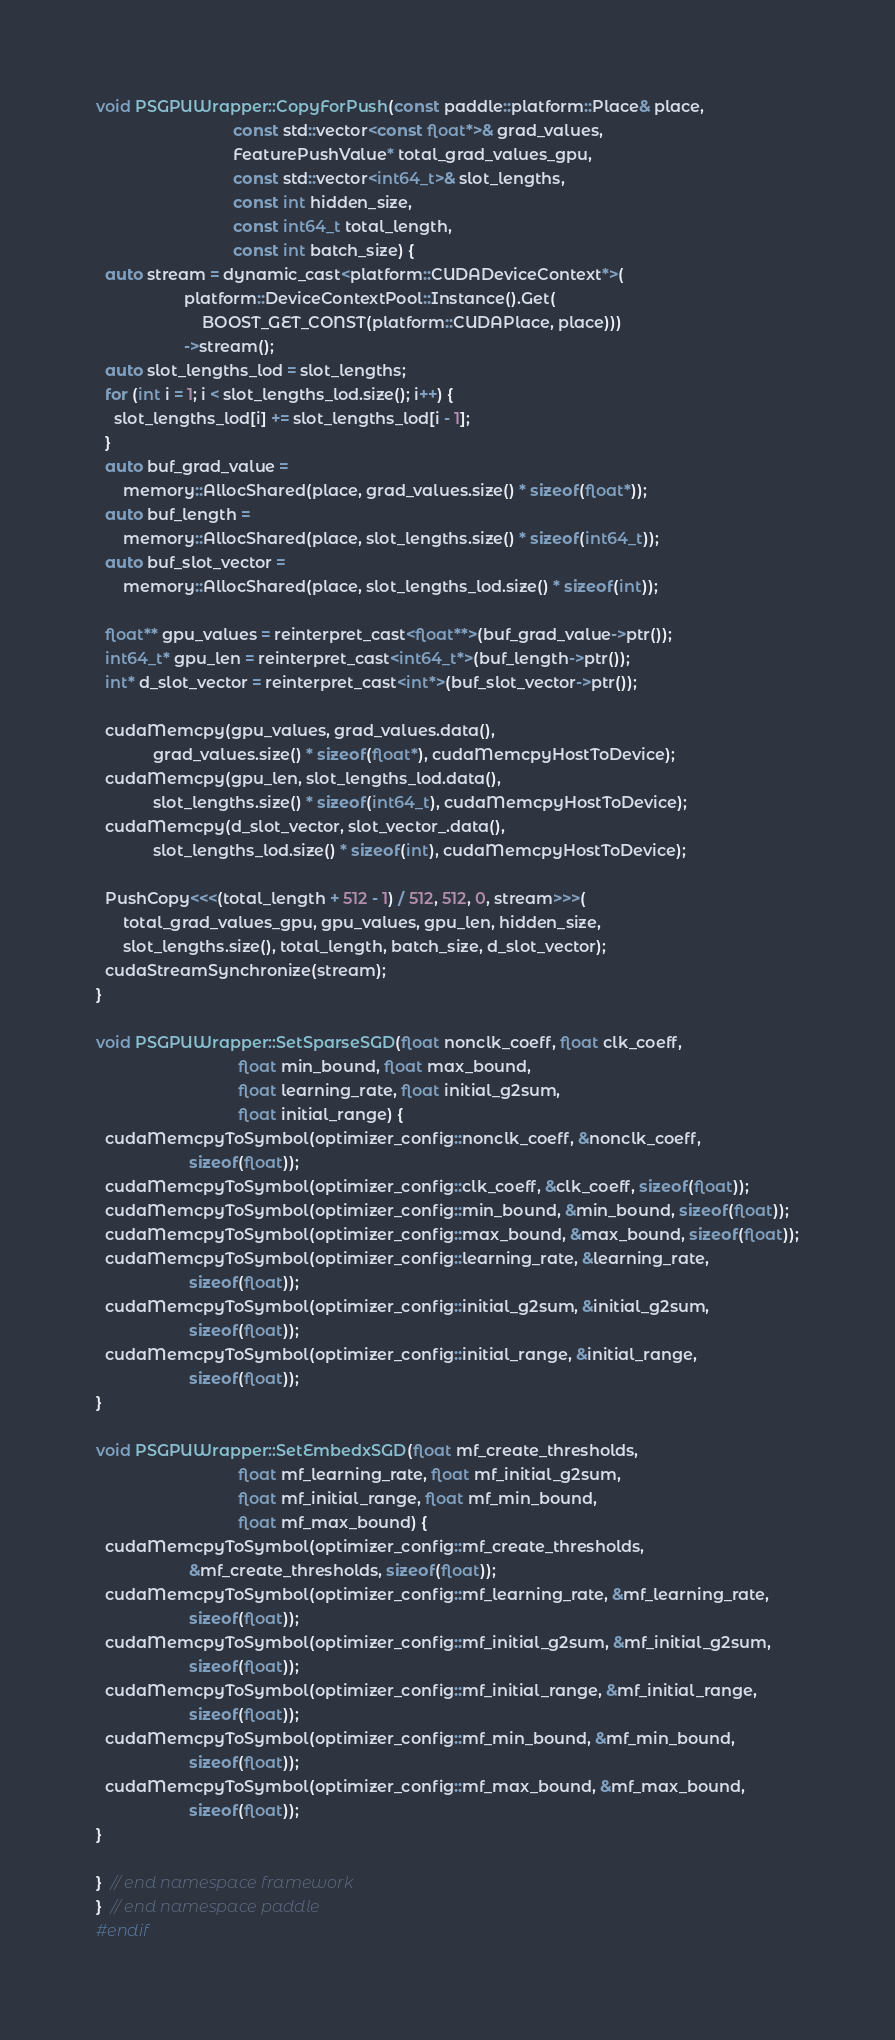Convert code to text. <code><loc_0><loc_0><loc_500><loc_500><_Cuda_>void PSGPUWrapper::CopyForPush(const paddle::platform::Place& place,
                               const std::vector<const float*>& grad_values,
                               FeaturePushValue* total_grad_values_gpu,
                               const std::vector<int64_t>& slot_lengths,
                               const int hidden_size,
                               const int64_t total_length,
                               const int batch_size) {
  auto stream = dynamic_cast<platform::CUDADeviceContext*>(
                    platform::DeviceContextPool::Instance().Get(
                        BOOST_GET_CONST(platform::CUDAPlace, place)))
                    ->stream();
  auto slot_lengths_lod = slot_lengths;
  for (int i = 1; i < slot_lengths_lod.size(); i++) {
    slot_lengths_lod[i] += slot_lengths_lod[i - 1];
  }
  auto buf_grad_value =
      memory::AllocShared(place, grad_values.size() * sizeof(float*));
  auto buf_length =
      memory::AllocShared(place, slot_lengths.size() * sizeof(int64_t));
  auto buf_slot_vector =
      memory::AllocShared(place, slot_lengths_lod.size() * sizeof(int));

  float** gpu_values = reinterpret_cast<float**>(buf_grad_value->ptr());
  int64_t* gpu_len = reinterpret_cast<int64_t*>(buf_length->ptr());
  int* d_slot_vector = reinterpret_cast<int*>(buf_slot_vector->ptr());

  cudaMemcpy(gpu_values, grad_values.data(),
             grad_values.size() * sizeof(float*), cudaMemcpyHostToDevice);
  cudaMemcpy(gpu_len, slot_lengths_lod.data(),
             slot_lengths.size() * sizeof(int64_t), cudaMemcpyHostToDevice);
  cudaMemcpy(d_slot_vector, slot_vector_.data(),
             slot_lengths_lod.size() * sizeof(int), cudaMemcpyHostToDevice);

  PushCopy<<<(total_length + 512 - 1) / 512, 512, 0, stream>>>(
      total_grad_values_gpu, gpu_values, gpu_len, hidden_size,
      slot_lengths.size(), total_length, batch_size, d_slot_vector);
  cudaStreamSynchronize(stream);
}

void PSGPUWrapper::SetSparseSGD(float nonclk_coeff, float clk_coeff,
                                float min_bound, float max_bound,
                                float learning_rate, float initial_g2sum,
                                float initial_range) {
  cudaMemcpyToSymbol(optimizer_config::nonclk_coeff, &nonclk_coeff,
                     sizeof(float));
  cudaMemcpyToSymbol(optimizer_config::clk_coeff, &clk_coeff, sizeof(float));
  cudaMemcpyToSymbol(optimizer_config::min_bound, &min_bound, sizeof(float));
  cudaMemcpyToSymbol(optimizer_config::max_bound, &max_bound, sizeof(float));
  cudaMemcpyToSymbol(optimizer_config::learning_rate, &learning_rate,
                     sizeof(float));
  cudaMemcpyToSymbol(optimizer_config::initial_g2sum, &initial_g2sum,
                     sizeof(float));
  cudaMemcpyToSymbol(optimizer_config::initial_range, &initial_range,
                     sizeof(float));
}

void PSGPUWrapper::SetEmbedxSGD(float mf_create_thresholds,
                                float mf_learning_rate, float mf_initial_g2sum,
                                float mf_initial_range, float mf_min_bound,
                                float mf_max_bound) {
  cudaMemcpyToSymbol(optimizer_config::mf_create_thresholds,
                     &mf_create_thresholds, sizeof(float));
  cudaMemcpyToSymbol(optimizer_config::mf_learning_rate, &mf_learning_rate,
                     sizeof(float));
  cudaMemcpyToSymbol(optimizer_config::mf_initial_g2sum, &mf_initial_g2sum,
                     sizeof(float));
  cudaMemcpyToSymbol(optimizer_config::mf_initial_range, &mf_initial_range,
                     sizeof(float));
  cudaMemcpyToSymbol(optimizer_config::mf_min_bound, &mf_min_bound,
                     sizeof(float));
  cudaMemcpyToSymbol(optimizer_config::mf_max_bound, &mf_max_bound,
                     sizeof(float));
}

}  // end namespace framework
}  // end namespace paddle
#endif
</code> 